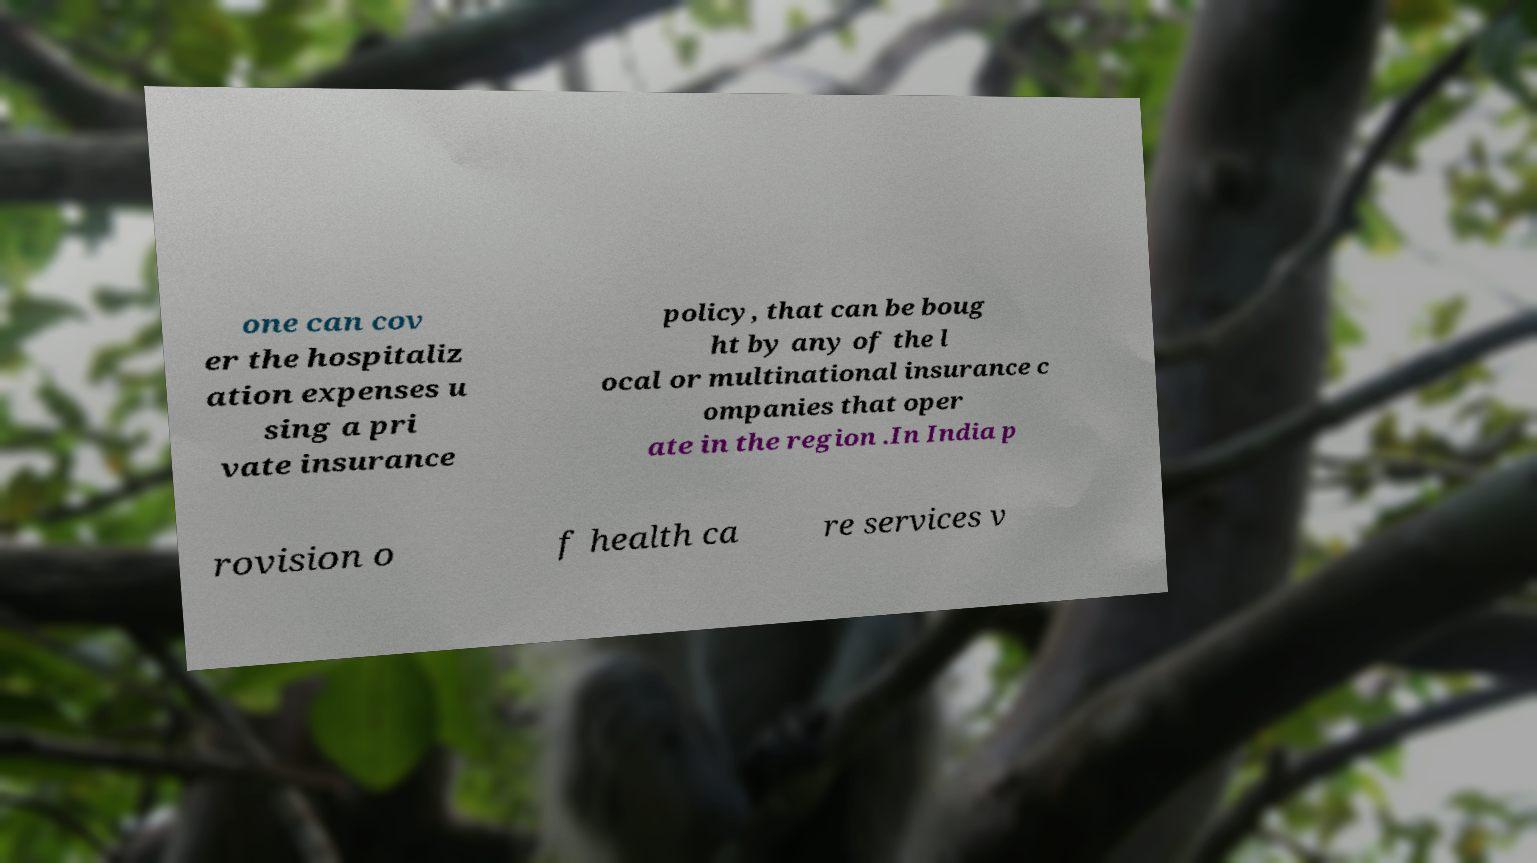There's text embedded in this image that I need extracted. Can you transcribe it verbatim? one can cov er the hospitaliz ation expenses u sing a pri vate insurance policy, that can be boug ht by any of the l ocal or multinational insurance c ompanies that oper ate in the region .In India p rovision o f health ca re services v 